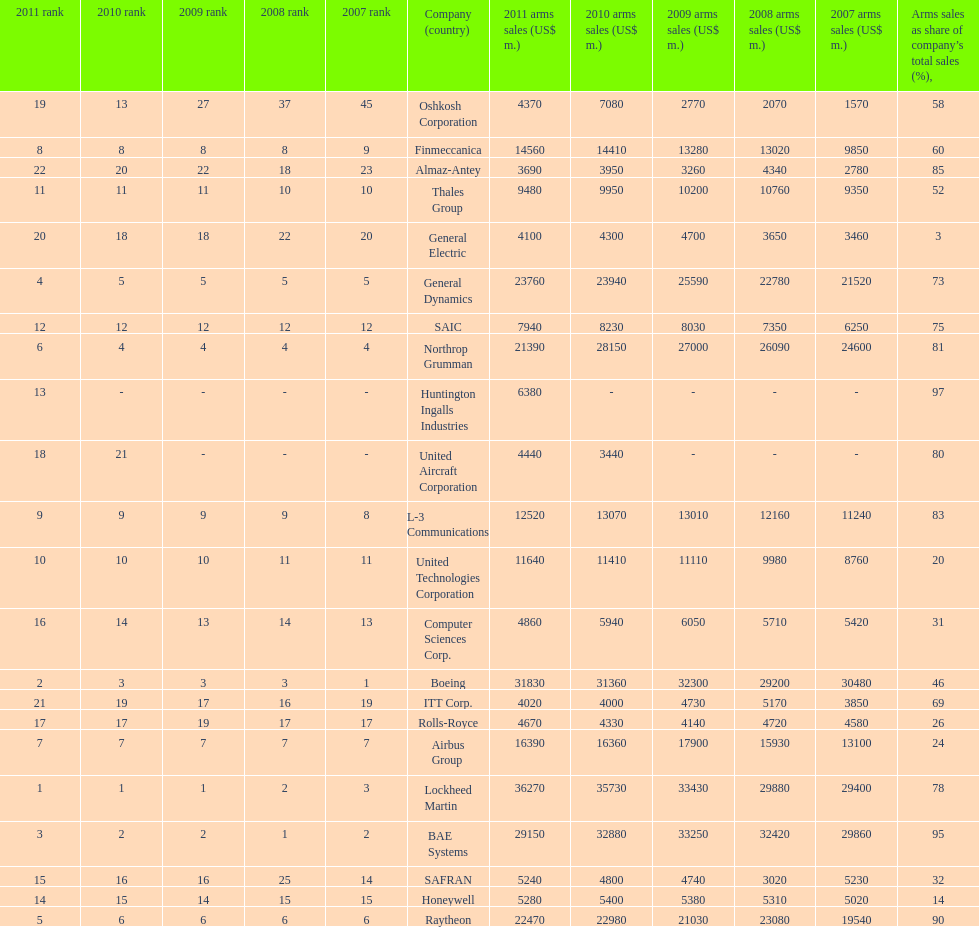How many companies are under the united states? 14. 